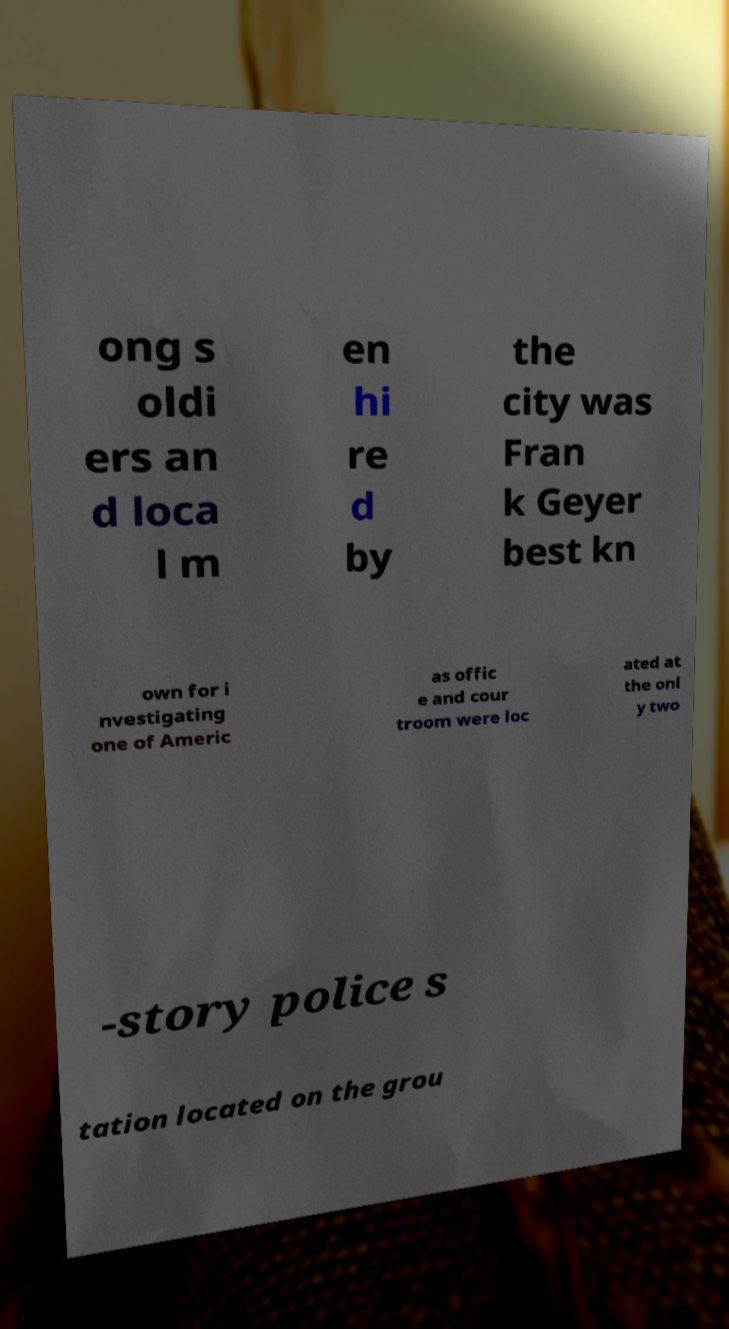Please read and relay the text visible in this image. What does it say? ong s oldi ers an d loca l m en hi re d by the city was Fran k Geyer best kn own for i nvestigating one of Americ as offic e and cour troom were loc ated at the onl y two -story police s tation located on the grou 